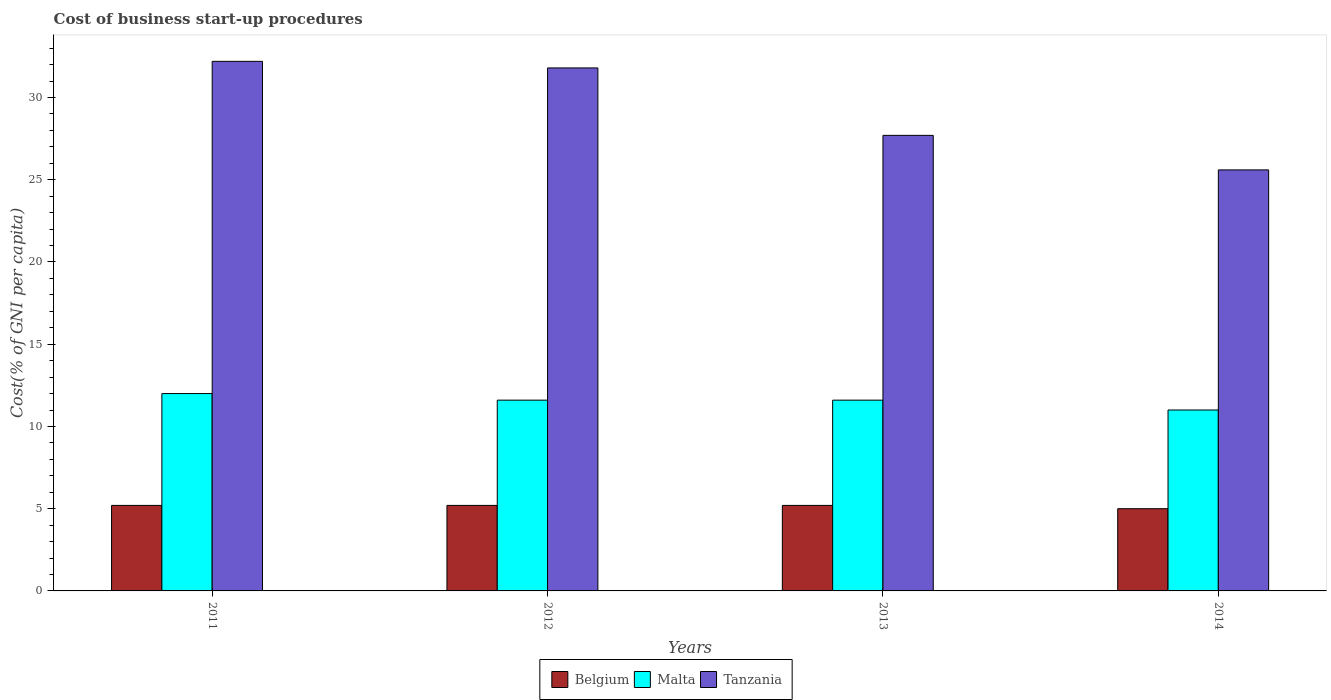How many groups of bars are there?
Offer a terse response. 4. Are the number of bars per tick equal to the number of legend labels?
Your answer should be very brief. Yes. Are the number of bars on each tick of the X-axis equal?
Offer a terse response. Yes. How many bars are there on the 3rd tick from the left?
Provide a short and direct response. 3. How many bars are there on the 3rd tick from the right?
Make the answer very short. 3. What is the cost of business start-up procedures in Malta in 2014?
Make the answer very short. 11. Across all years, what is the maximum cost of business start-up procedures in Malta?
Offer a terse response. 12. Across all years, what is the minimum cost of business start-up procedures in Tanzania?
Give a very brief answer. 25.6. In which year was the cost of business start-up procedures in Malta maximum?
Make the answer very short. 2011. What is the total cost of business start-up procedures in Malta in the graph?
Give a very brief answer. 46.2. What is the difference between the cost of business start-up procedures in Belgium in 2011 and that in 2012?
Keep it short and to the point. 0. What is the difference between the cost of business start-up procedures in Malta in 2014 and the cost of business start-up procedures in Tanzania in 2013?
Make the answer very short. -16.7. What is the average cost of business start-up procedures in Belgium per year?
Ensure brevity in your answer.  5.15. What is the ratio of the cost of business start-up procedures in Belgium in 2011 to that in 2012?
Your answer should be very brief. 1. Is the cost of business start-up procedures in Belgium in 2011 less than that in 2013?
Offer a very short reply. No. Is the difference between the cost of business start-up procedures in Malta in 2011 and 2014 greater than the difference between the cost of business start-up procedures in Belgium in 2011 and 2014?
Your answer should be very brief. Yes. What is the difference between the highest and the second highest cost of business start-up procedures in Malta?
Ensure brevity in your answer.  0.4. What is the difference between the highest and the lowest cost of business start-up procedures in Tanzania?
Provide a short and direct response. 6.6. In how many years, is the cost of business start-up procedures in Malta greater than the average cost of business start-up procedures in Malta taken over all years?
Offer a terse response. 3. What does the 2nd bar from the left in 2013 represents?
Your answer should be very brief. Malta. How many bars are there?
Your response must be concise. 12. Are all the bars in the graph horizontal?
Provide a succinct answer. No. Are the values on the major ticks of Y-axis written in scientific E-notation?
Ensure brevity in your answer.  No. Does the graph contain any zero values?
Offer a terse response. No. Does the graph contain grids?
Your response must be concise. No. How many legend labels are there?
Provide a succinct answer. 3. What is the title of the graph?
Give a very brief answer. Cost of business start-up procedures. Does "Low income" appear as one of the legend labels in the graph?
Ensure brevity in your answer.  No. What is the label or title of the X-axis?
Ensure brevity in your answer.  Years. What is the label or title of the Y-axis?
Keep it short and to the point. Cost(% of GNI per capita). What is the Cost(% of GNI per capita) of Belgium in 2011?
Ensure brevity in your answer.  5.2. What is the Cost(% of GNI per capita) in Malta in 2011?
Offer a very short reply. 12. What is the Cost(% of GNI per capita) in Tanzania in 2011?
Offer a very short reply. 32.2. What is the Cost(% of GNI per capita) in Belgium in 2012?
Your response must be concise. 5.2. What is the Cost(% of GNI per capita) of Malta in 2012?
Offer a terse response. 11.6. What is the Cost(% of GNI per capita) in Tanzania in 2012?
Give a very brief answer. 31.8. What is the Cost(% of GNI per capita) of Malta in 2013?
Provide a succinct answer. 11.6. What is the Cost(% of GNI per capita) of Tanzania in 2013?
Offer a terse response. 27.7. What is the Cost(% of GNI per capita) in Malta in 2014?
Your answer should be very brief. 11. What is the Cost(% of GNI per capita) of Tanzania in 2014?
Offer a very short reply. 25.6. Across all years, what is the maximum Cost(% of GNI per capita) in Belgium?
Your answer should be very brief. 5.2. Across all years, what is the maximum Cost(% of GNI per capita) in Malta?
Provide a succinct answer. 12. Across all years, what is the maximum Cost(% of GNI per capita) of Tanzania?
Make the answer very short. 32.2. Across all years, what is the minimum Cost(% of GNI per capita) in Tanzania?
Keep it short and to the point. 25.6. What is the total Cost(% of GNI per capita) of Belgium in the graph?
Provide a short and direct response. 20.6. What is the total Cost(% of GNI per capita) in Malta in the graph?
Make the answer very short. 46.2. What is the total Cost(% of GNI per capita) of Tanzania in the graph?
Your response must be concise. 117.3. What is the difference between the Cost(% of GNI per capita) in Belgium in 2011 and that in 2012?
Keep it short and to the point. 0. What is the difference between the Cost(% of GNI per capita) of Malta in 2011 and that in 2012?
Keep it short and to the point. 0.4. What is the difference between the Cost(% of GNI per capita) in Tanzania in 2011 and that in 2012?
Provide a succinct answer. 0.4. What is the difference between the Cost(% of GNI per capita) of Belgium in 2011 and that in 2013?
Provide a succinct answer. 0. What is the difference between the Cost(% of GNI per capita) of Tanzania in 2011 and that in 2013?
Keep it short and to the point. 4.5. What is the difference between the Cost(% of GNI per capita) in Belgium in 2011 and that in 2014?
Provide a short and direct response. 0.2. What is the difference between the Cost(% of GNI per capita) in Malta in 2011 and that in 2014?
Your answer should be very brief. 1. What is the difference between the Cost(% of GNI per capita) in Tanzania in 2011 and that in 2014?
Offer a terse response. 6.6. What is the difference between the Cost(% of GNI per capita) in Belgium in 2012 and that in 2013?
Give a very brief answer. 0. What is the difference between the Cost(% of GNI per capita) of Malta in 2012 and that in 2013?
Give a very brief answer. 0. What is the difference between the Cost(% of GNI per capita) in Tanzania in 2012 and that in 2013?
Provide a short and direct response. 4.1. What is the difference between the Cost(% of GNI per capita) of Belgium in 2012 and that in 2014?
Offer a terse response. 0.2. What is the difference between the Cost(% of GNI per capita) of Tanzania in 2012 and that in 2014?
Offer a very short reply. 6.2. What is the difference between the Cost(% of GNI per capita) in Belgium in 2013 and that in 2014?
Offer a very short reply. 0.2. What is the difference between the Cost(% of GNI per capita) in Belgium in 2011 and the Cost(% of GNI per capita) in Tanzania in 2012?
Make the answer very short. -26.6. What is the difference between the Cost(% of GNI per capita) in Malta in 2011 and the Cost(% of GNI per capita) in Tanzania in 2012?
Ensure brevity in your answer.  -19.8. What is the difference between the Cost(% of GNI per capita) of Belgium in 2011 and the Cost(% of GNI per capita) of Tanzania in 2013?
Provide a succinct answer. -22.5. What is the difference between the Cost(% of GNI per capita) of Malta in 2011 and the Cost(% of GNI per capita) of Tanzania in 2013?
Your response must be concise. -15.7. What is the difference between the Cost(% of GNI per capita) of Belgium in 2011 and the Cost(% of GNI per capita) of Malta in 2014?
Offer a very short reply. -5.8. What is the difference between the Cost(% of GNI per capita) of Belgium in 2011 and the Cost(% of GNI per capita) of Tanzania in 2014?
Give a very brief answer. -20.4. What is the difference between the Cost(% of GNI per capita) in Belgium in 2012 and the Cost(% of GNI per capita) in Malta in 2013?
Offer a terse response. -6.4. What is the difference between the Cost(% of GNI per capita) of Belgium in 2012 and the Cost(% of GNI per capita) of Tanzania in 2013?
Your response must be concise. -22.5. What is the difference between the Cost(% of GNI per capita) of Malta in 2012 and the Cost(% of GNI per capita) of Tanzania in 2013?
Give a very brief answer. -16.1. What is the difference between the Cost(% of GNI per capita) in Belgium in 2012 and the Cost(% of GNI per capita) in Malta in 2014?
Your answer should be compact. -5.8. What is the difference between the Cost(% of GNI per capita) in Belgium in 2012 and the Cost(% of GNI per capita) in Tanzania in 2014?
Ensure brevity in your answer.  -20.4. What is the difference between the Cost(% of GNI per capita) in Belgium in 2013 and the Cost(% of GNI per capita) in Tanzania in 2014?
Give a very brief answer. -20.4. What is the difference between the Cost(% of GNI per capita) in Malta in 2013 and the Cost(% of GNI per capita) in Tanzania in 2014?
Provide a short and direct response. -14. What is the average Cost(% of GNI per capita) of Belgium per year?
Your answer should be compact. 5.15. What is the average Cost(% of GNI per capita) in Malta per year?
Keep it short and to the point. 11.55. What is the average Cost(% of GNI per capita) of Tanzania per year?
Your answer should be compact. 29.32. In the year 2011, what is the difference between the Cost(% of GNI per capita) in Belgium and Cost(% of GNI per capita) in Malta?
Keep it short and to the point. -6.8. In the year 2011, what is the difference between the Cost(% of GNI per capita) of Belgium and Cost(% of GNI per capita) of Tanzania?
Provide a short and direct response. -27. In the year 2011, what is the difference between the Cost(% of GNI per capita) of Malta and Cost(% of GNI per capita) of Tanzania?
Provide a succinct answer. -20.2. In the year 2012, what is the difference between the Cost(% of GNI per capita) of Belgium and Cost(% of GNI per capita) of Malta?
Keep it short and to the point. -6.4. In the year 2012, what is the difference between the Cost(% of GNI per capita) in Belgium and Cost(% of GNI per capita) in Tanzania?
Make the answer very short. -26.6. In the year 2012, what is the difference between the Cost(% of GNI per capita) of Malta and Cost(% of GNI per capita) of Tanzania?
Provide a short and direct response. -20.2. In the year 2013, what is the difference between the Cost(% of GNI per capita) in Belgium and Cost(% of GNI per capita) in Malta?
Ensure brevity in your answer.  -6.4. In the year 2013, what is the difference between the Cost(% of GNI per capita) of Belgium and Cost(% of GNI per capita) of Tanzania?
Keep it short and to the point. -22.5. In the year 2013, what is the difference between the Cost(% of GNI per capita) of Malta and Cost(% of GNI per capita) of Tanzania?
Offer a terse response. -16.1. In the year 2014, what is the difference between the Cost(% of GNI per capita) in Belgium and Cost(% of GNI per capita) in Malta?
Keep it short and to the point. -6. In the year 2014, what is the difference between the Cost(% of GNI per capita) in Belgium and Cost(% of GNI per capita) in Tanzania?
Offer a very short reply. -20.6. In the year 2014, what is the difference between the Cost(% of GNI per capita) in Malta and Cost(% of GNI per capita) in Tanzania?
Your answer should be very brief. -14.6. What is the ratio of the Cost(% of GNI per capita) of Malta in 2011 to that in 2012?
Keep it short and to the point. 1.03. What is the ratio of the Cost(% of GNI per capita) of Tanzania in 2011 to that in 2012?
Provide a succinct answer. 1.01. What is the ratio of the Cost(% of GNI per capita) in Belgium in 2011 to that in 2013?
Your answer should be compact. 1. What is the ratio of the Cost(% of GNI per capita) of Malta in 2011 to that in 2013?
Your answer should be compact. 1.03. What is the ratio of the Cost(% of GNI per capita) of Tanzania in 2011 to that in 2013?
Give a very brief answer. 1.16. What is the ratio of the Cost(% of GNI per capita) in Malta in 2011 to that in 2014?
Your answer should be compact. 1.09. What is the ratio of the Cost(% of GNI per capita) of Tanzania in 2011 to that in 2014?
Offer a very short reply. 1.26. What is the ratio of the Cost(% of GNI per capita) of Tanzania in 2012 to that in 2013?
Your answer should be compact. 1.15. What is the ratio of the Cost(% of GNI per capita) of Malta in 2012 to that in 2014?
Give a very brief answer. 1.05. What is the ratio of the Cost(% of GNI per capita) of Tanzania in 2012 to that in 2014?
Keep it short and to the point. 1.24. What is the ratio of the Cost(% of GNI per capita) in Malta in 2013 to that in 2014?
Your answer should be compact. 1.05. What is the ratio of the Cost(% of GNI per capita) of Tanzania in 2013 to that in 2014?
Keep it short and to the point. 1.08. What is the difference between the highest and the second highest Cost(% of GNI per capita) in Malta?
Provide a short and direct response. 0.4. What is the difference between the highest and the lowest Cost(% of GNI per capita) in Belgium?
Your answer should be very brief. 0.2. 